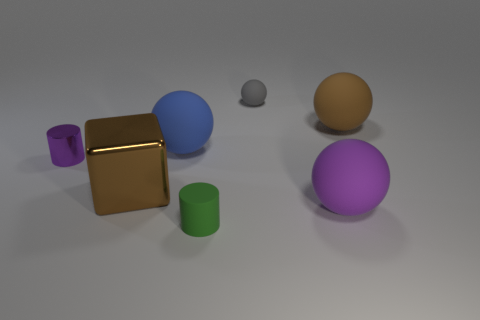What color is the matte sphere that is in front of the brown block?
Provide a succinct answer. Purple. Is there a cylinder to the right of the large matte sphere that is to the left of the tiny green cylinder?
Offer a very short reply. Yes. Does the tiny sphere have the same color as the large rubber thing behind the blue sphere?
Offer a terse response. No. Is there a small cyan thing made of the same material as the tiny gray sphere?
Provide a succinct answer. No. What number of gray matte balls are there?
Offer a very short reply. 1. The large brown object in front of the big brown object that is behind the large blue rubber thing is made of what material?
Offer a terse response. Metal. There is a small sphere that is made of the same material as the big purple ball; what is its color?
Offer a terse response. Gray. Is the size of the shiny thing that is on the right side of the purple shiny cylinder the same as the matte object behind the brown ball?
Your response must be concise. No. How many blocks are either big gray rubber objects or big brown matte things?
Provide a short and direct response. 0. Do the small object that is on the left side of the big brown cube and the block have the same material?
Offer a very short reply. Yes. 